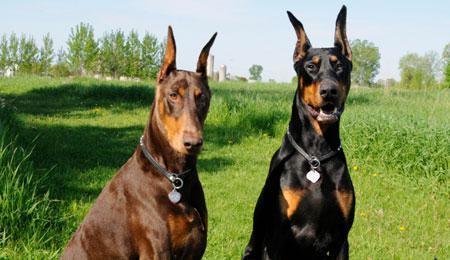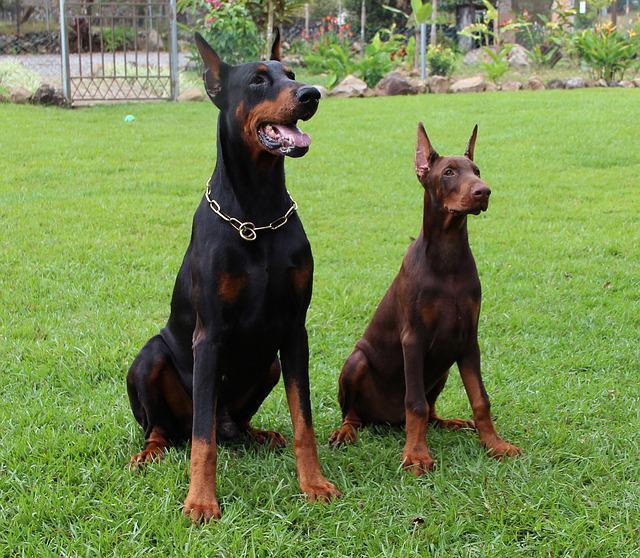The first image is the image on the left, the second image is the image on the right. Assess this claim about the two images: "there are two dogs side by side , at least one dog has dog tags on it's collar". Correct or not? Answer yes or no. Yes. The first image is the image on the left, the second image is the image on the right. Analyze the images presented: Is the assertion "One dog stands alone in the image on the left, and the right image shows a person standing by at least one doberman." valid? Answer yes or no. No. 